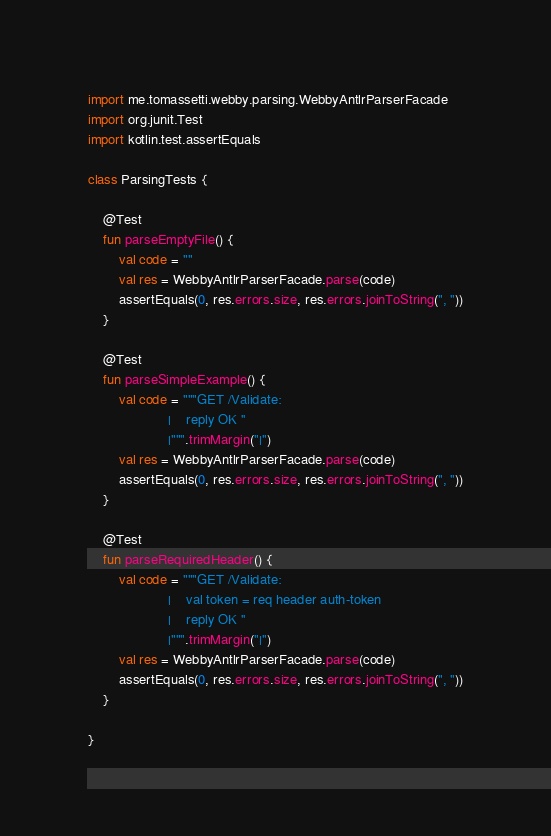<code> <loc_0><loc_0><loc_500><loc_500><_Kotlin_>import me.tomassetti.webby.parsing.WebbyAntlrParserFacade
import org.junit.Test
import kotlin.test.assertEquals

class ParsingTests {

    @Test
    fun parseEmptyFile() {
        val code = ""
        val res = WebbyAntlrParserFacade.parse(code)
        assertEquals(0, res.errors.size, res.errors.joinToString(", "))
    }

    @Test
    fun parseSimpleExample() {
        val code = """GET /Validate:
                     |    reply OK ''
                     |""".trimMargin("|")
        val res = WebbyAntlrParserFacade.parse(code)
        assertEquals(0, res.errors.size, res.errors.joinToString(", "))
    }

    @Test
    fun parseRequiredHeader() {
        val code = """GET /Validate:
                     |    val token = req header auth-token
                     |    reply OK ''
                     |""".trimMargin("|")
        val res = WebbyAntlrParserFacade.parse(code)
        assertEquals(0, res.errors.size, res.errors.joinToString(", "))
    }

}
</code> 